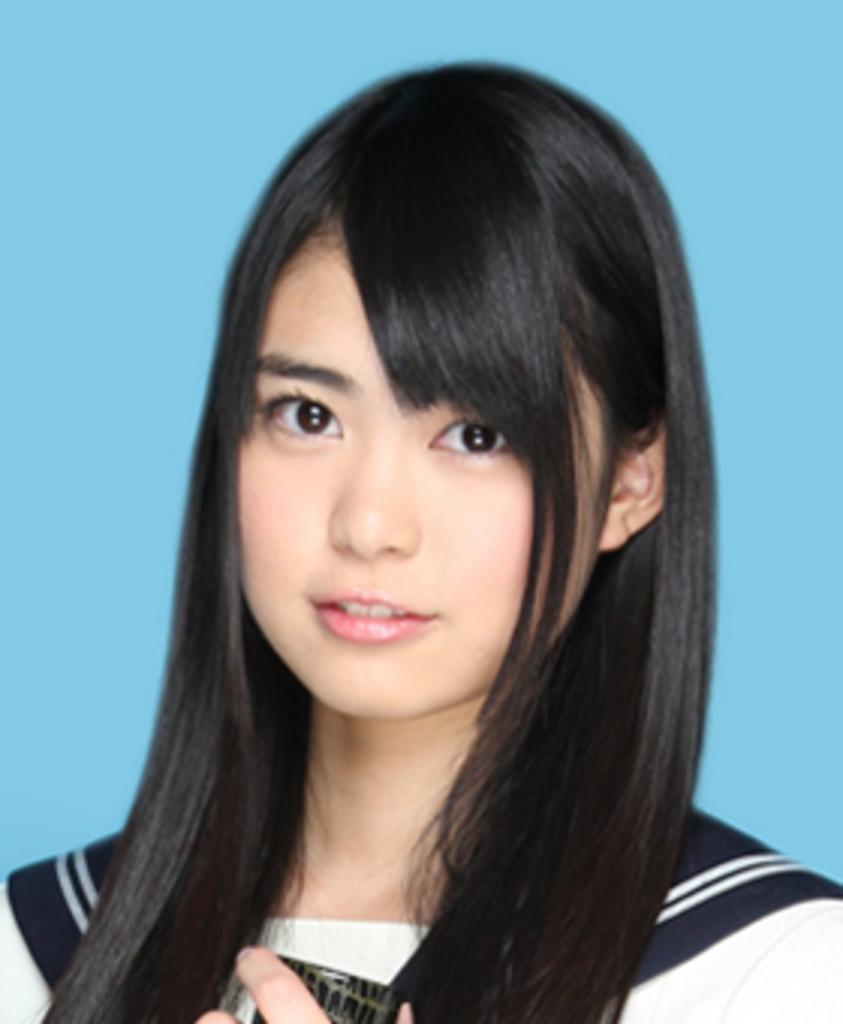Who is present in the image? There is a woman in the image. What can be seen in the background of the image? The background of the image is blue. What type of cloth is the woman using to make her journey easier in the image? There is no cloth or journey mentioned in the image; it only features a woman with a blue background. 